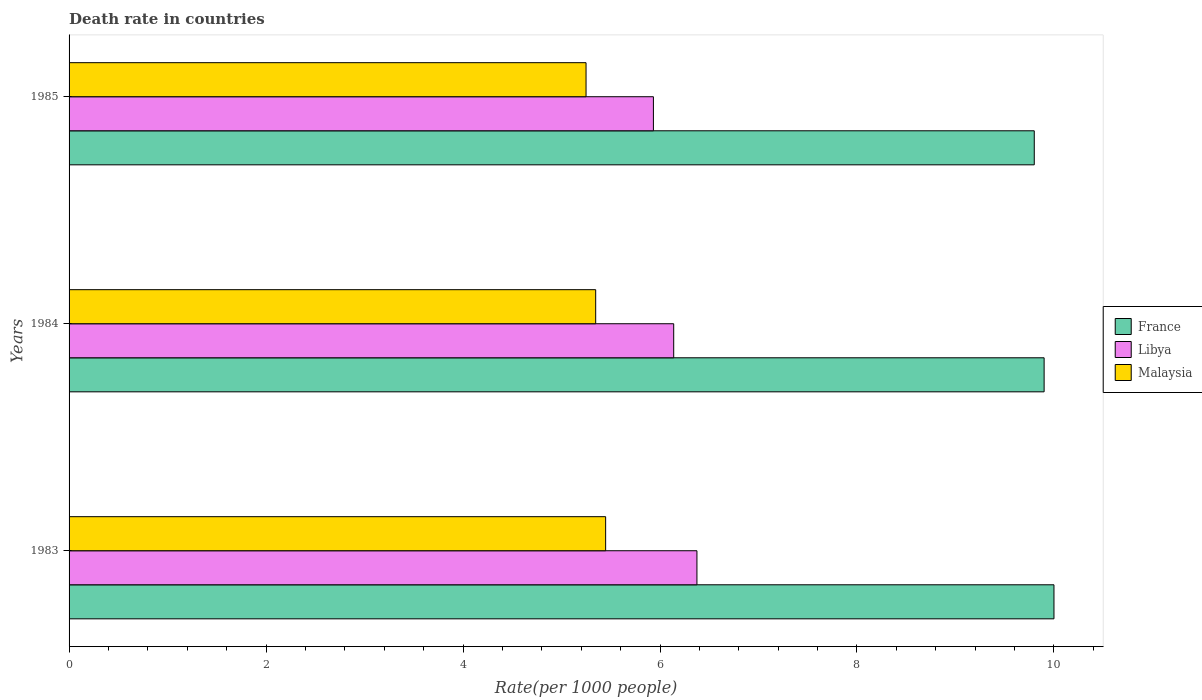How many groups of bars are there?
Your answer should be very brief. 3. Are the number of bars per tick equal to the number of legend labels?
Provide a short and direct response. Yes. Are the number of bars on each tick of the Y-axis equal?
Keep it short and to the point. Yes. How many bars are there on the 1st tick from the bottom?
Keep it short and to the point. 3. In how many cases, is the number of bars for a given year not equal to the number of legend labels?
Provide a short and direct response. 0. What is the death rate in Libya in 1984?
Keep it short and to the point. 6.14. Across all years, what is the maximum death rate in Malaysia?
Provide a succinct answer. 5.45. Across all years, what is the minimum death rate in France?
Ensure brevity in your answer.  9.8. In which year was the death rate in Libya minimum?
Offer a terse response. 1985. What is the total death rate in Libya in the graph?
Provide a short and direct response. 18.45. What is the difference between the death rate in Libya in 1983 and that in 1985?
Your answer should be very brief. 0.44. What is the difference between the death rate in Malaysia in 1985 and the death rate in France in 1983?
Provide a succinct answer. -4.75. What is the average death rate in Libya per year?
Provide a succinct answer. 6.15. In the year 1985, what is the difference between the death rate in France and death rate in Malaysia?
Ensure brevity in your answer.  4.55. In how many years, is the death rate in Libya greater than 10 ?
Provide a short and direct response. 0. What is the ratio of the death rate in Malaysia in 1984 to that in 1985?
Offer a very short reply. 1.02. Is the death rate in France in 1983 less than that in 1985?
Offer a terse response. No. What is the difference between the highest and the second highest death rate in France?
Your answer should be very brief. 0.1. What is the difference between the highest and the lowest death rate in Libya?
Offer a very short reply. 0.44. In how many years, is the death rate in Malaysia greater than the average death rate in Malaysia taken over all years?
Make the answer very short. 1. What does the 1st bar from the bottom in 1985 represents?
Give a very brief answer. France. Is it the case that in every year, the sum of the death rate in Malaysia and death rate in Libya is greater than the death rate in France?
Keep it short and to the point. Yes. How many bars are there?
Your answer should be compact. 9. How many years are there in the graph?
Give a very brief answer. 3. What is the difference between two consecutive major ticks on the X-axis?
Ensure brevity in your answer.  2. Are the values on the major ticks of X-axis written in scientific E-notation?
Your answer should be very brief. No. Does the graph contain grids?
Your response must be concise. No. How many legend labels are there?
Make the answer very short. 3. How are the legend labels stacked?
Give a very brief answer. Vertical. What is the title of the graph?
Provide a short and direct response. Death rate in countries. Does "Togo" appear as one of the legend labels in the graph?
Your response must be concise. No. What is the label or title of the X-axis?
Give a very brief answer. Rate(per 1000 people). What is the Rate(per 1000 people) in France in 1983?
Provide a short and direct response. 10. What is the Rate(per 1000 people) in Libya in 1983?
Make the answer very short. 6.38. What is the Rate(per 1000 people) of Malaysia in 1983?
Your answer should be very brief. 5.45. What is the Rate(per 1000 people) of France in 1984?
Make the answer very short. 9.9. What is the Rate(per 1000 people) in Libya in 1984?
Your answer should be compact. 6.14. What is the Rate(per 1000 people) of Malaysia in 1984?
Provide a short and direct response. 5.35. What is the Rate(per 1000 people) in France in 1985?
Your response must be concise. 9.8. What is the Rate(per 1000 people) in Libya in 1985?
Make the answer very short. 5.93. What is the Rate(per 1000 people) of Malaysia in 1985?
Provide a succinct answer. 5.25. Across all years, what is the maximum Rate(per 1000 people) in France?
Make the answer very short. 10. Across all years, what is the maximum Rate(per 1000 people) in Libya?
Provide a succinct answer. 6.38. Across all years, what is the maximum Rate(per 1000 people) in Malaysia?
Your answer should be compact. 5.45. Across all years, what is the minimum Rate(per 1000 people) in Libya?
Keep it short and to the point. 5.93. Across all years, what is the minimum Rate(per 1000 people) in Malaysia?
Your answer should be compact. 5.25. What is the total Rate(per 1000 people) in France in the graph?
Provide a succinct answer. 29.7. What is the total Rate(per 1000 people) of Libya in the graph?
Provide a succinct answer. 18.45. What is the total Rate(per 1000 people) of Malaysia in the graph?
Offer a terse response. 16.04. What is the difference between the Rate(per 1000 people) in France in 1983 and that in 1984?
Provide a succinct answer. 0.1. What is the difference between the Rate(per 1000 people) in Libya in 1983 and that in 1984?
Ensure brevity in your answer.  0.24. What is the difference between the Rate(per 1000 people) in Malaysia in 1983 and that in 1984?
Ensure brevity in your answer.  0.1. What is the difference between the Rate(per 1000 people) in France in 1983 and that in 1985?
Offer a terse response. 0.2. What is the difference between the Rate(per 1000 people) of Libya in 1983 and that in 1985?
Offer a terse response. 0.44. What is the difference between the Rate(per 1000 people) of Malaysia in 1983 and that in 1985?
Provide a short and direct response. 0.2. What is the difference between the Rate(per 1000 people) of France in 1984 and that in 1985?
Keep it short and to the point. 0.1. What is the difference between the Rate(per 1000 people) of Libya in 1984 and that in 1985?
Provide a short and direct response. 0.21. What is the difference between the Rate(per 1000 people) of Malaysia in 1984 and that in 1985?
Keep it short and to the point. 0.1. What is the difference between the Rate(per 1000 people) in France in 1983 and the Rate(per 1000 people) in Libya in 1984?
Your response must be concise. 3.86. What is the difference between the Rate(per 1000 people) of France in 1983 and the Rate(per 1000 people) of Malaysia in 1984?
Your response must be concise. 4.65. What is the difference between the Rate(per 1000 people) in Libya in 1983 and the Rate(per 1000 people) in Malaysia in 1984?
Provide a short and direct response. 1.03. What is the difference between the Rate(per 1000 people) in France in 1983 and the Rate(per 1000 people) in Libya in 1985?
Ensure brevity in your answer.  4.07. What is the difference between the Rate(per 1000 people) in France in 1983 and the Rate(per 1000 people) in Malaysia in 1985?
Provide a short and direct response. 4.75. What is the difference between the Rate(per 1000 people) of Libya in 1983 and the Rate(per 1000 people) of Malaysia in 1985?
Offer a very short reply. 1.13. What is the difference between the Rate(per 1000 people) of France in 1984 and the Rate(per 1000 people) of Libya in 1985?
Your answer should be compact. 3.97. What is the difference between the Rate(per 1000 people) of France in 1984 and the Rate(per 1000 people) of Malaysia in 1985?
Offer a terse response. 4.65. What is the difference between the Rate(per 1000 people) of Libya in 1984 and the Rate(per 1000 people) of Malaysia in 1985?
Ensure brevity in your answer.  0.89. What is the average Rate(per 1000 people) in Libya per year?
Offer a terse response. 6.15. What is the average Rate(per 1000 people) in Malaysia per year?
Offer a terse response. 5.35. In the year 1983, what is the difference between the Rate(per 1000 people) in France and Rate(per 1000 people) in Libya?
Make the answer very short. 3.62. In the year 1983, what is the difference between the Rate(per 1000 people) in France and Rate(per 1000 people) in Malaysia?
Make the answer very short. 4.55. In the year 1983, what is the difference between the Rate(per 1000 people) in Libya and Rate(per 1000 people) in Malaysia?
Offer a terse response. 0.93. In the year 1984, what is the difference between the Rate(per 1000 people) in France and Rate(per 1000 people) in Libya?
Keep it short and to the point. 3.76. In the year 1984, what is the difference between the Rate(per 1000 people) in France and Rate(per 1000 people) in Malaysia?
Ensure brevity in your answer.  4.55. In the year 1984, what is the difference between the Rate(per 1000 people) of Libya and Rate(per 1000 people) of Malaysia?
Provide a succinct answer. 0.79. In the year 1985, what is the difference between the Rate(per 1000 people) in France and Rate(per 1000 people) in Libya?
Give a very brief answer. 3.87. In the year 1985, what is the difference between the Rate(per 1000 people) of France and Rate(per 1000 people) of Malaysia?
Offer a terse response. 4.55. In the year 1985, what is the difference between the Rate(per 1000 people) in Libya and Rate(per 1000 people) in Malaysia?
Give a very brief answer. 0.68. What is the ratio of the Rate(per 1000 people) of Libya in 1983 to that in 1984?
Make the answer very short. 1.04. What is the ratio of the Rate(per 1000 people) of Malaysia in 1983 to that in 1984?
Offer a terse response. 1.02. What is the ratio of the Rate(per 1000 people) of France in 1983 to that in 1985?
Give a very brief answer. 1.02. What is the ratio of the Rate(per 1000 people) of Libya in 1983 to that in 1985?
Keep it short and to the point. 1.07. What is the ratio of the Rate(per 1000 people) in Malaysia in 1983 to that in 1985?
Offer a very short reply. 1.04. What is the ratio of the Rate(per 1000 people) in France in 1984 to that in 1985?
Give a very brief answer. 1.01. What is the ratio of the Rate(per 1000 people) in Libya in 1984 to that in 1985?
Give a very brief answer. 1.03. What is the ratio of the Rate(per 1000 people) in Malaysia in 1984 to that in 1985?
Offer a terse response. 1.02. What is the difference between the highest and the second highest Rate(per 1000 people) in France?
Keep it short and to the point. 0.1. What is the difference between the highest and the second highest Rate(per 1000 people) of Libya?
Your answer should be very brief. 0.24. What is the difference between the highest and the second highest Rate(per 1000 people) in Malaysia?
Keep it short and to the point. 0.1. What is the difference between the highest and the lowest Rate(per 1000 people) in Libya?
Ensure brevity in your answer.  0.44. What is the difference between the highest and the lowest Rate(per 1000 people) of Malaysia?
Your answer should be compact. 0.2. 